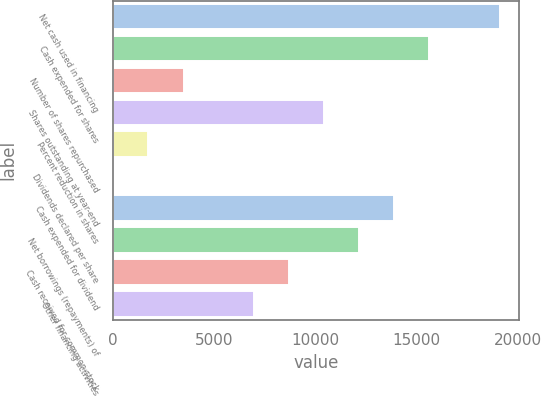Convert chart. <chart><loc_0><loc_0><loc_500><loc_500><bar_chart><fcel>Net cash used in financing<fcel>Cash expended for shares<fcel>Number of shares repurchased<fcel>Shares outstanding at year-end<fcel>Percent reduction in shares<fcel>Dividends declared per share<fcel>Cash expended for dividend<fcel>Net borrowings (repayments) of<fcel>Cash received for common stock<fcel>Other financing activities<nl><fcel>19095.7<fcel>15624.2<fcel>3473.98<fcel>10417<fcel>1738.23<fcel>2.48<fcel>13888.5<fcel>12152.7<fcel>8681.23<fcel>6945.48<nl></chart> 